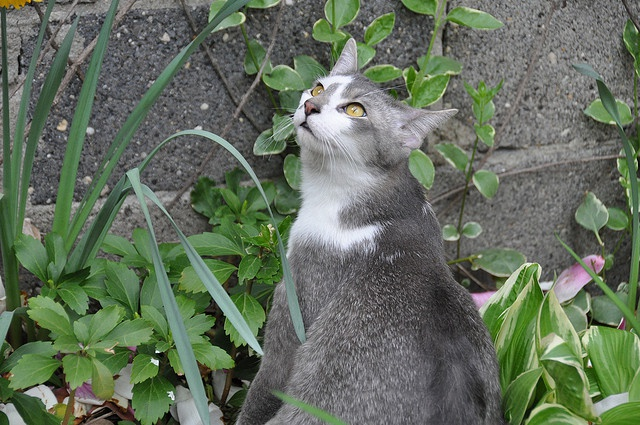Describe the objects in this image and their specific colors. I can see a cat in olive, gray, darkgray, black, and lightgray tones in this image. 